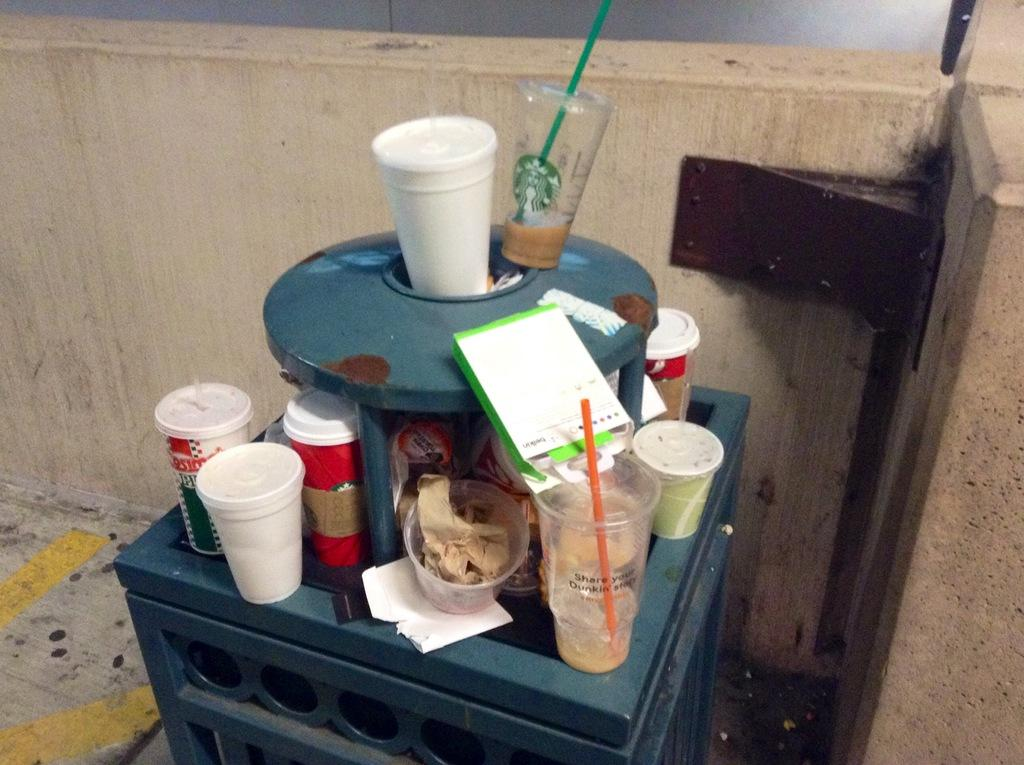What type of objects can be seen in the image? There are cups, a straw, papers, and boxes in the image. What is used for drinking in the image? There is a straw in the image, which is typically used for drinking. What type of material might the papers be made of? The papers in the image might be made of paper or cardstock. What are the boxes used for in the image? The boxes in the image might be used for storage or organization. What objects are placed on a grey color object in the image? There are objects on a grey color object in the image, but the specific objects are not mentioned in the facts. What color is the wall in the image? The wall in the image is cream color. What type of flowers can be seen growing on the wall in the image? There are no flowers visible on the wall in the image; it is cream color. 